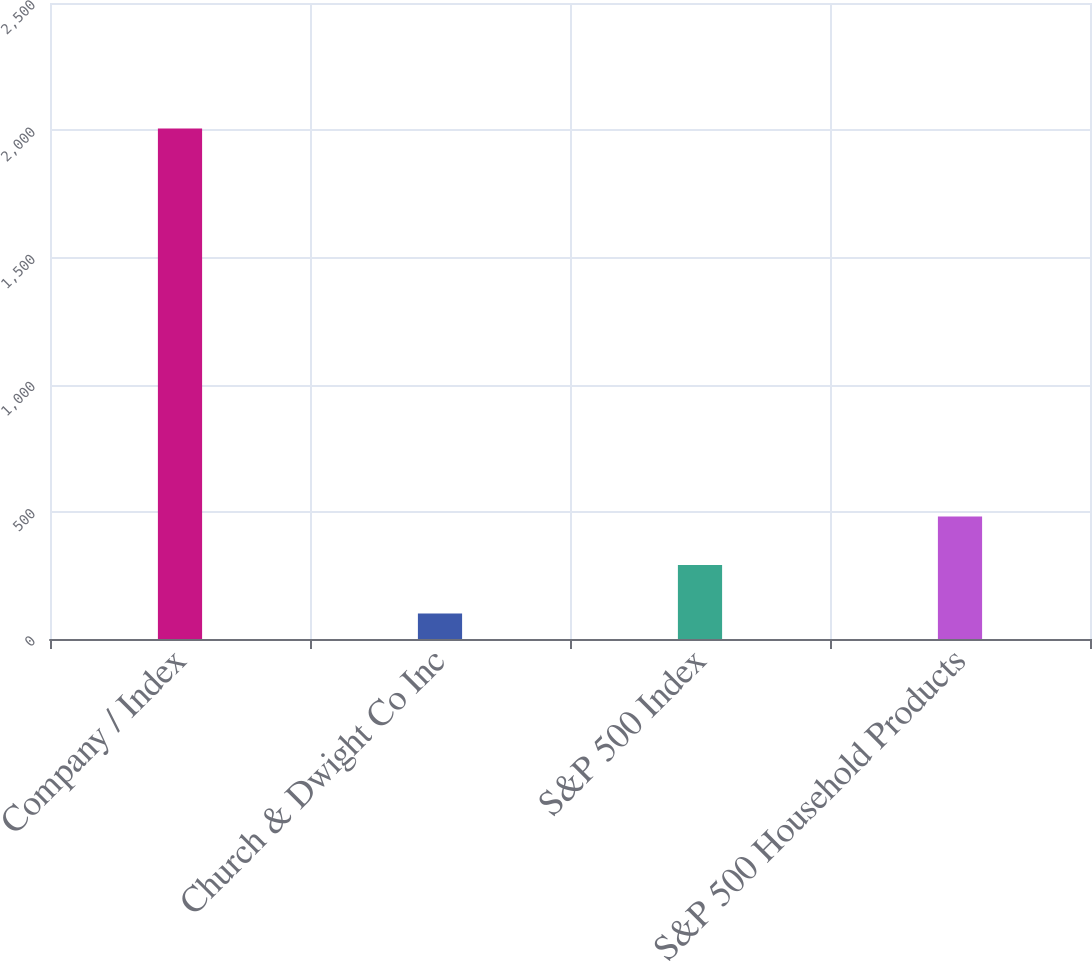<chart> <loc_0><loc_0><loc_500><loc_500><bar_chart><fcel>Company / Index<fcel>Church & Dwight Co Inc<fcel>S&P 500 Index<fcel>S&P 500 Household Products<nl><fcel>2007<fcel>100<fcel>290.7<fcel>481.4<nl></chart> 